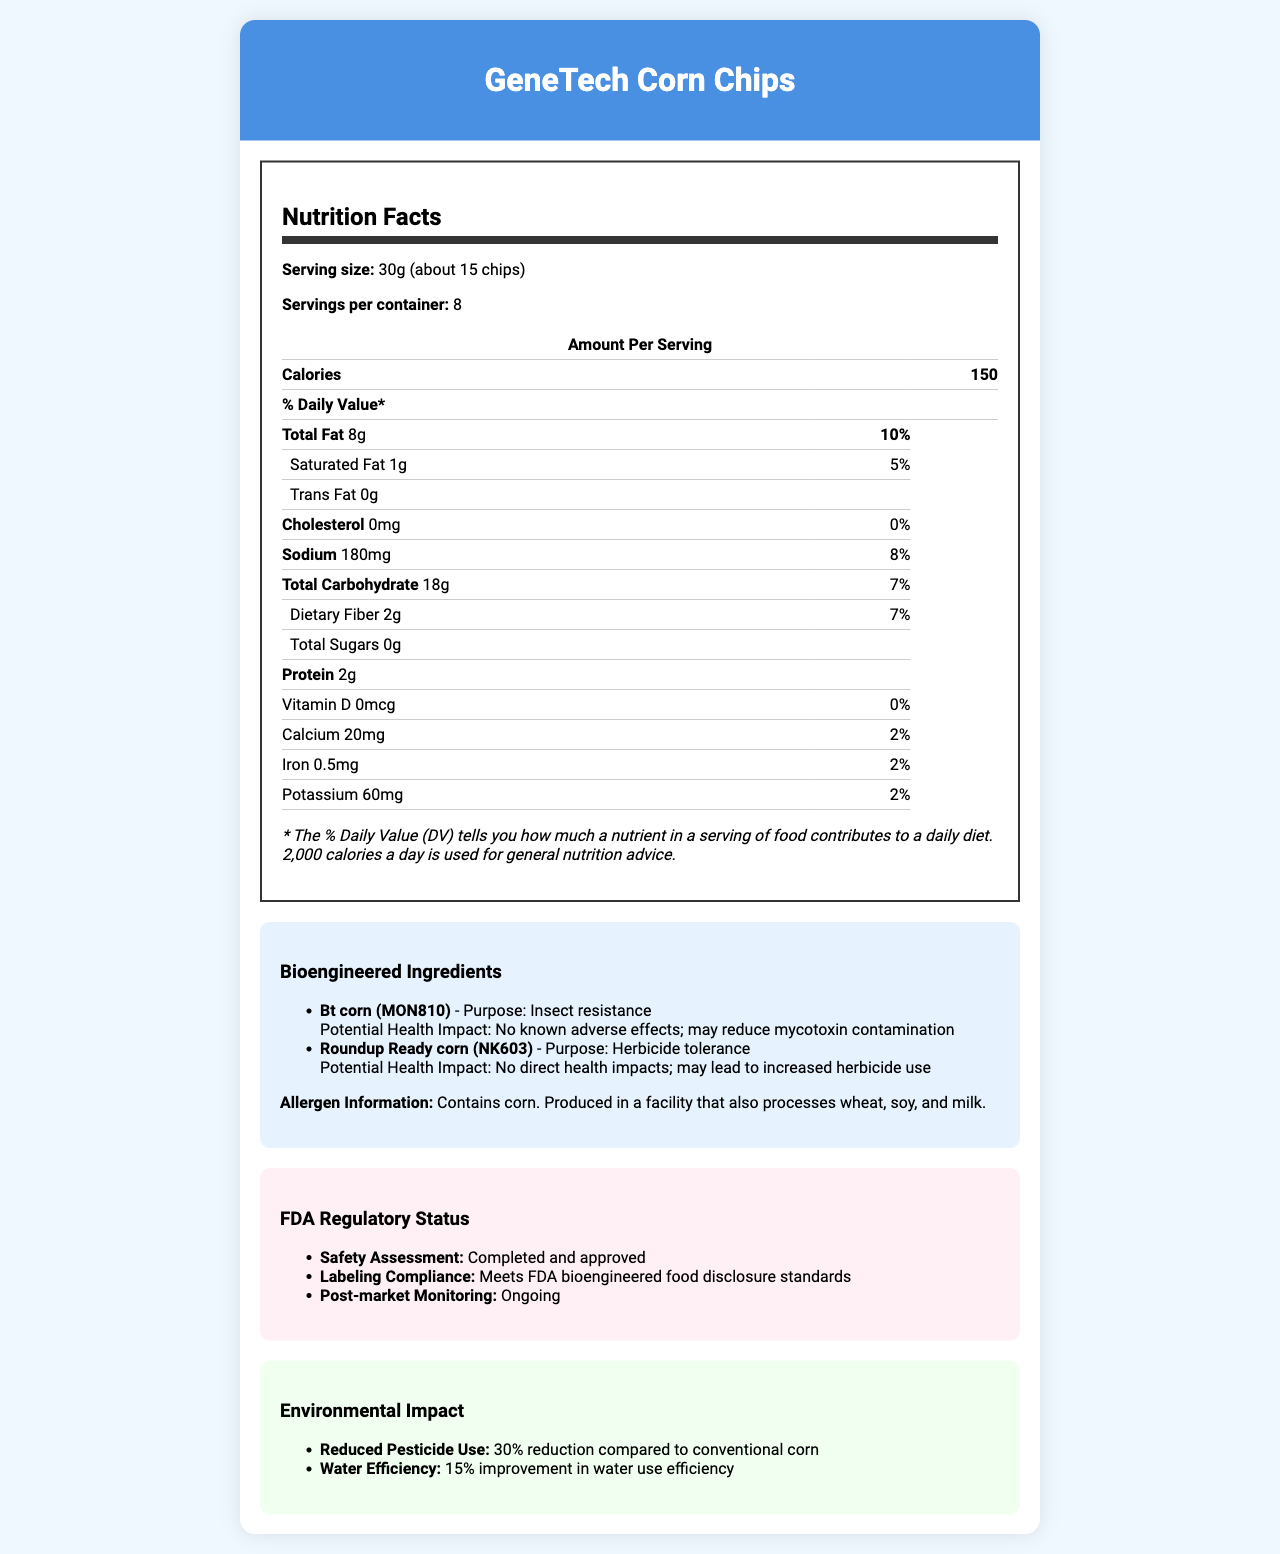what is the serving size of GeneTech Corn Chips? The serving size is listed at the beginning of the "Nutrition Facts" section.
Answer: 30g (about 15 chips) how many calories are in one serving of GeneTech Corn Chips? This information is provided under "Amount Per Serving" right next to the "Calories" label.
Answer: 150 calories what is the percentage of Daily Value for total fat per serving? The percentage of Daily Value is given next to the total fat amount (8g).
Answer: 10% which bioengineered ingredient in GeneTech Corn Chips is designed for herbicide tolerance? This detail is mentioned under the "Bioengineered Ingredients" section, stating the purpose of each bioengineered ingredient.
Answer: Roundup Ready corn (NK603) what traceability method is used for supply chain verification? This is found under the "Traceability Information" section which describes the methods used for verification.
Answer: Blockchain-enabled how much dietary fiber does one serving provide? This information is under the "Total Carbohydrate" section, specifically listed as "Dietary Fiber".
Answer: 2g what potential health impact is associated with Bt corn (MON810)? This is listed under the potential health impact section for the bioengineered ingredient Bt corn (MON810).
Answer: No known adverse effects; may reduce mycotoxin contamination how much sodium is in one serving? The sodium content is listed with its corresponding daily value percentage (8%).
Answer: 180mg what increased nutrient enhancements does GeneTech Corn Chips have? (Choose all that apply) A. Increased Vitamin E B. Increased Vitamin C C. Increased Lysine D. Increased Calcium The increased nutrient enhancements are Vitamin E and Lysine, as listed under the "Nutritional Enhancements" section.
Answer: A and C which allergen is mentioned on the label that is directly associated with the product itself? A. Wheat B. Soy C. Milk D. Corn The product directly contains corn, as specified in the "Allergen Information" section.
Answer: D have the bioengineered ingredients in GeneTech Corn Chips been approved by the FDA? According to the "FDA Regulatory Status" section, the safety assessment has been completed and approved.
Answer: Yes does the document provide information on environmental impact? There is a dedicated section titled "Environmental Impact", discussing reduced pesticide use and improved water efficiency.
Answer: Yes summarize the main points covered in the nutrition and ingredient detail sections of the document. This summary captures the key elements covered in the document, highlighting its focus on nutritional content, bioengineered ingredients, regulatory status, and environmental and traceability factors.
Answer: The document outlines the nutritional information for GeneTech Corn Chips, including serving size, calories, macronutrients, and specific nutrient values. It also details the bioengineered ingredients with their purposes and potential health impacts, allergen information, FDA regulatory status, increased nutrient enhancements, environmental impact, and traceability information. what is the manufacturer of GeneTech Corn Chips? The document does not provide any information about the manufacturer of GeneTech Corn Chips.
Answer: Cannot be determined 